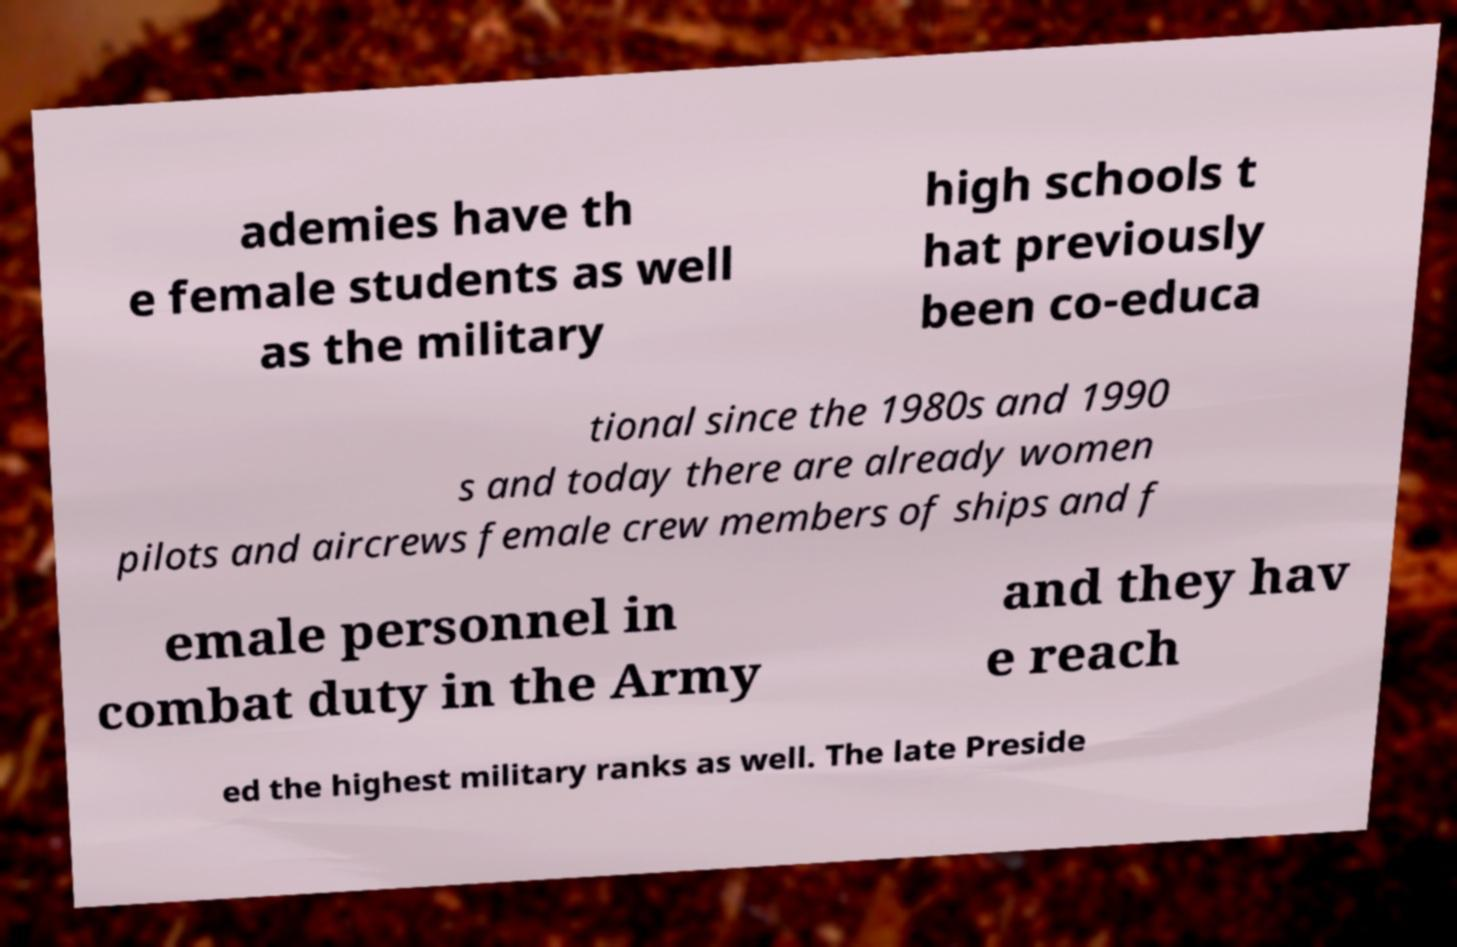Please read and relay the text visible in this image. What does it say? ademies have th e female students as well as the military high schools t hat previously been co-educa tional since the 1980s and 1990 s and today there are already women pilots and aircrews female crew members of ships and f emale personnel in combat duty in the Army and they hav e reach ed the highest military ranks as well. The late Preside 